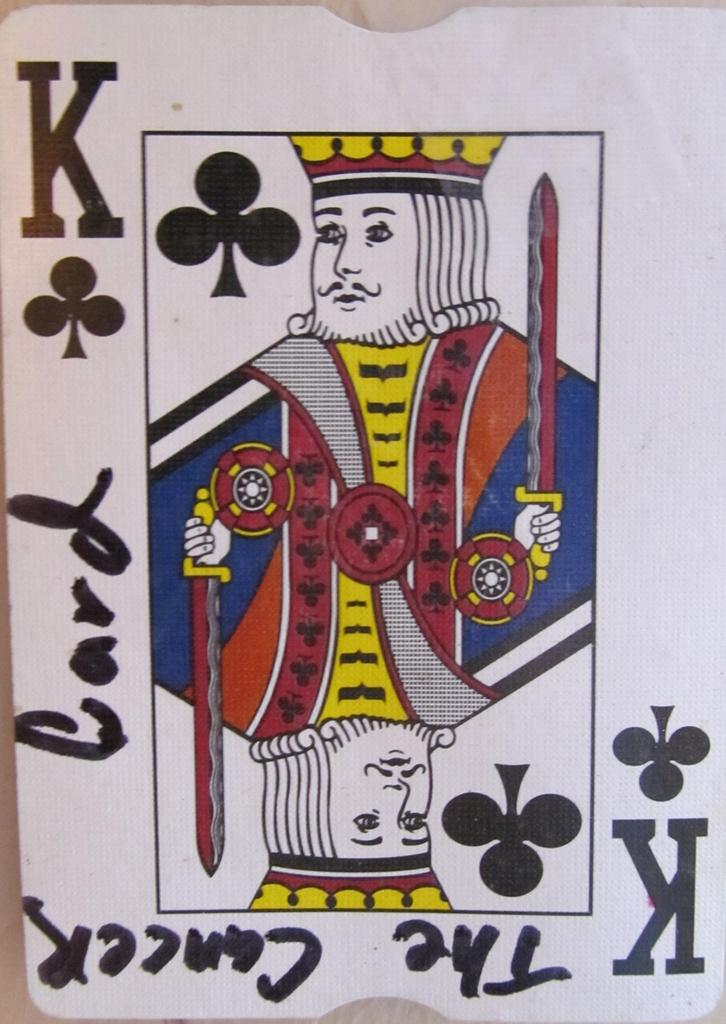<image>
Share a concise interpretation of the image provided. A King of clubs playing card with The Cancer Card written on it. 